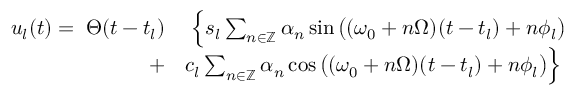Convert formula to latex. <formula><loc_0><loc_0><loc_500><loc_500>\begin{array} { r l } { u _ { l } ( t ) = \, \Theta ( t - t _ { l } ) } & { \, \left \{ s _ { l } \sum _ { n \in \mathbb { Z } } \alpha _ { n } \sin \left ( ( \omega _ { 0 } + n \Omega ) ( t - t _ { l } ) + n \phi _ { l } \right ) } \\ { + } & { c _ { l } \sum _ { n \in \mathbb { Z } } \alpha _ { n } \cos \left ( ( \omega _ { 0 } + n \Omega ) ( t - t _ { l } ) + n \phi _ { l } \right ) \right \} } \end{array}</formula> 